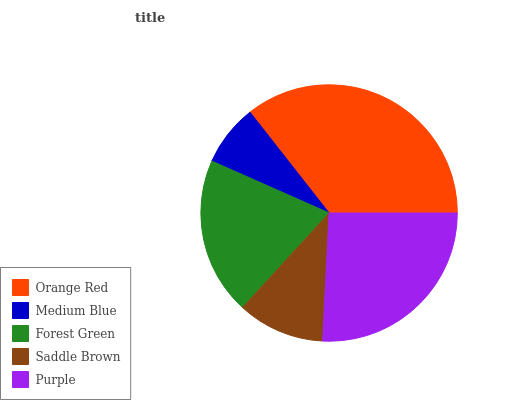Is Medium Blue the minimum?
Answer yes or no. Yes. Is Orange Red the maximum?
Answer yes or no. Yes. Is Forest Green the minimum?
Answer yes or no. No. Is Forest Green the maximum?
Answer yes or no. No. Is Forest Green greater than Medium Blue?
Answer yes or no. Yes. Is Medium Blue less than Forest Green?
Answer yes or no. Yes. Is Medium Blue greater than Forest Green?
Answer yes or no. No. Is Forest Green less than Medium Blue?
Answer yes or no. No. Is Forest Green the high median?
Answer yes or no. Yes. Is Forest Green the low median?
Answer yes or no. Yes. Is Purple the high median?
Answer yes or no. No. Is Purple the low median?
Answer yes or no. No. 